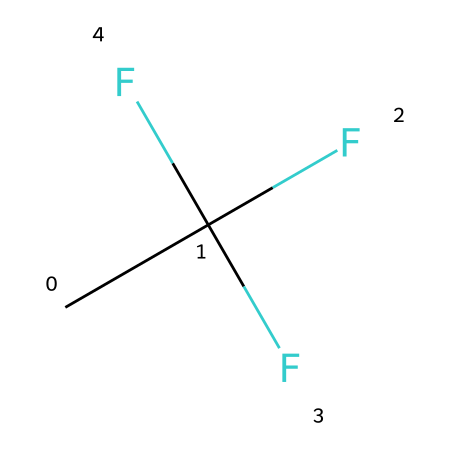What is the molecular formula of R-134a? The given SMILES representation CC(F)(F)F indicates the presence of two carbon atoms (C), a total of three fluorine atoms (F) attached to one carbon, and five hydrogen atoms (H) in the structure. Therefore, the molecular formula is C2H2F4.
Answer: C2H2F4 How many total atoms are present in R-134a? In the molecular formula C2H2F4, we have 2 carbon (C) atoms, 2 hydrogen (H) atoms, and 4 fluorine (F) atoms. Adding these gives a total of 8 atoms (2 + 2 + 4 = 8).
Answer: 8 What type of bonding is present in R-134a? The structure contains single bonds between carbon and hydrogen as well as carbon and fluorine, which are typical of aliphatic compounds. The presence of these bonds indicates that R-134a is saturated.
Answer: single bonds What is the main functional group of R-134a? Analyzing the structure, we see that R-134a is a halocarbon due to the presence of fluorine atoms. Halocarbons are characterized by the presence of halogen atoms (like F) bonded to carbon.
Answer: halocarbon How many fluorine atoms are in R-134a? The SMILES representation CC(F)(F)F shows that there are three fluorine atoms attached to one of the carbon atoms. The number is directly observable from the structure.
Answer: 3 Is R-134a a saturated or unsaturated compound? The structure CC(F)(F)F does not contain any double or triple bonds; it only has single bonds, indicating it is a saturated compound. This classification is made based on the types of bonds present in the molecular structure.
Answer: saturated What property makes R-134a effective as a refrigerant? R-134a has a low boiling point due to its molecular structure, allowing it to evaporate and absorb heat efficiently, which is key for refrigeration applications. This property results from its halogenated carbon structure, making it a good choice for heat transfer.
Answer: low boiling point 